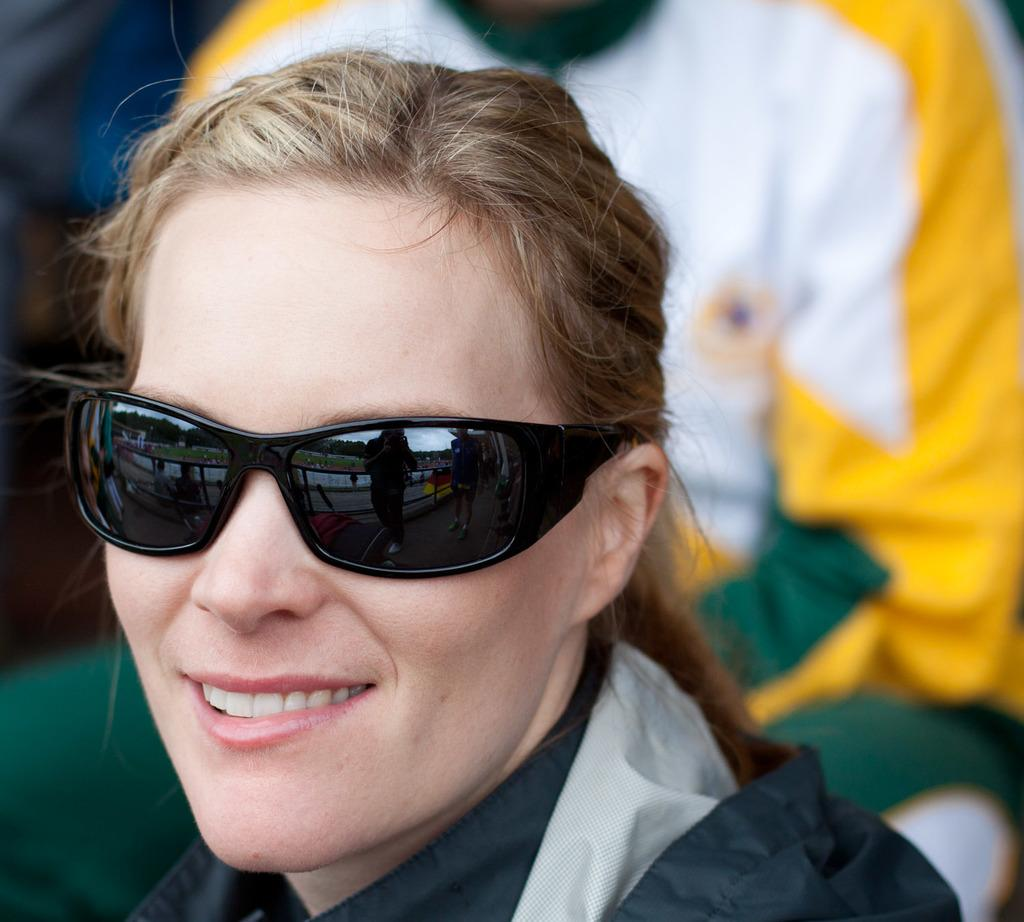Who can be seen in the image? There are people in the image. Can you describe one of the individuals in the image? There is a woman in the image. What accessory is the woman wearing? The woman is wearing spectacles. What type of farm animals can be seen in the image? There are no farm animals present in the image. How does the woman answer the question in the image? The image does not depict a conversation or question, so it is not possible to determine how the woman answers a question. 